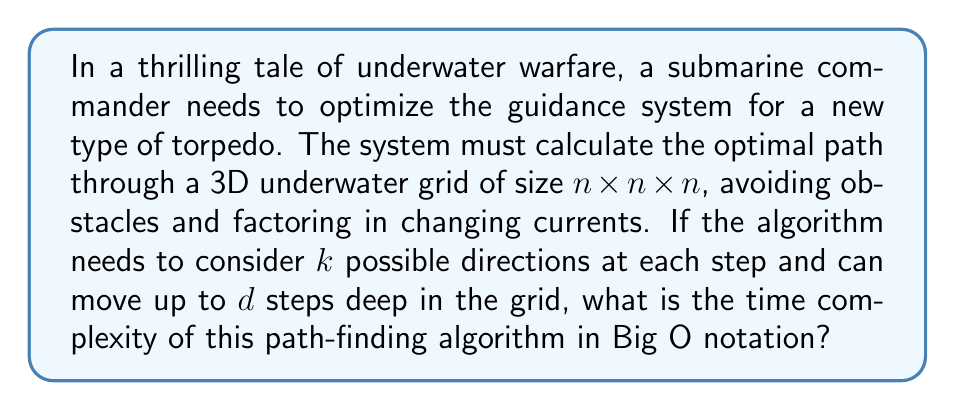Help me with this question. To solve this problem, let's break it down step-by-step:

1) The problem describes a path-finding algorithm in a 3D grid. This is similar to a depth-first search (DFS) or breadth-first search (BFS) algorithm, but with additional complexities.

2) The grid size is $n \times n \times n$, which means there are $n^3$ total cells to potentially explore.

3) At each step, the algorithm considers $k$ possible directions. This is like having a branching factor of $k$ in a search tree.

4) The algorithm can move up to $d$ steps deep in the grid. This limits the depth of our search tree.

5) In the worst case, the algorithm might need to explore every possible path up to depth $d$. This creates a search tree with $k$ branches at each level, going $d$ levels deep.

6) The number of nodes in such a tree would be:

   $1 + k + k^2 + k^3 + ... + k^d = \frac{k^{d+1} - 1}{k - 1}$

7) This sum is dominated by the $k^d$ term for large $k$ and $d$.

8) However, we also need to consider that we're constrained by the grid size. We can't explore more cells than exist in the grid, which is $n^3$.

9) Therefore, the time complexity will be the minimum of these two factors:

   $O(\min(k^d, n^3))$

This represents the number of cells the algorithm might need to explore in the worst case.
Answer: $O(\min(k^d, n^3))$ 